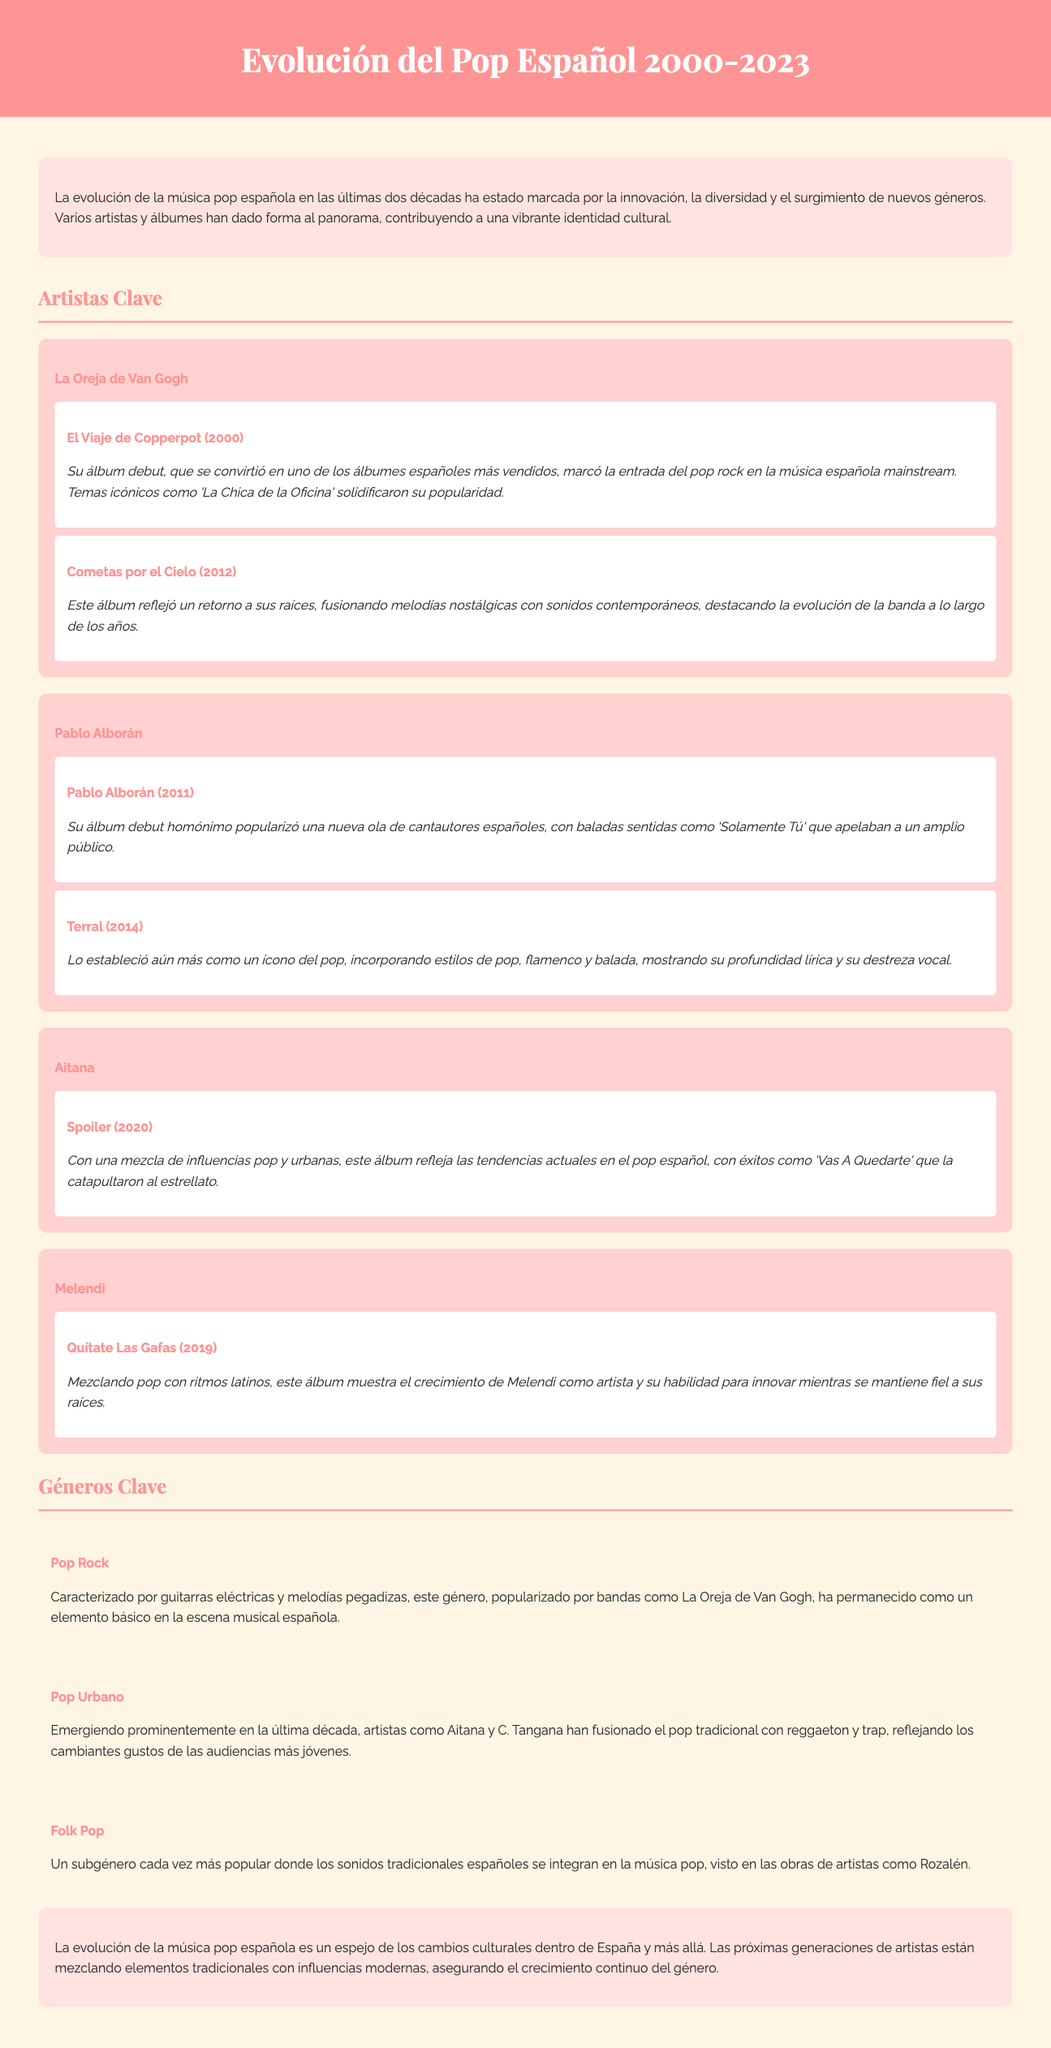¿Qué álbum debut lanzó La Oreja de Van Gogh? El álbum debut de La Oreja de Van Gogh es "El Viaje de Copperpot", que se menciona como uno de los álbumes españoles más vendidos.
Answer: El Viaje de Copperpot ¿Cuándo se lanzó "Pablo Alborán"? "Pablo Alborán" fue lanzado en 2011, según la información del documento.
Answer: 2011 ¿Qué género es característico de La Oreja de Van Gogh? El género característico de La Oreja de Van Gogh es el Pop Rock, mencionado en la sección de géneros clave.
Answer: Pop Rock ¿Cuál es el título del álbum de Aitana lanzado en 2020? El título del álbum de Aitana lanzado en 2020 es "Spoiler".
Answer: Spoiler ¿Cuál fue el impacto de "Cometas por el Cielo"? "Cometas por el Cielo" refleja un retorno a sus raíces, fusionando melodías nostálgicas con sonidos contemporáneos.
Answer: Retorno a sus raíces ¿Qué estilo de música incorpora "Terral" de Pablo Alborán? "Terral" incorpora estilos de pop, flamenco y balada, tal como se describe en el documento.
Answer: Pop, flamenco y balada ¿Quién es un artista destacado en el Pop Urbano? En el documento, Aitana es mencionada como una artista que destaca en el Pop Urbano.
Answer: Aitana ¿Cuál es el subgénero popular que integra sonidos tradicionales? El subgénero popular que integra sonidos tradicionales en el Pop se menciona como Folk Pop.
Answer: Folk Pop ¿Qué año corresponde al álbum "Quítate Las Gafas" de Melendi? "Quítate Las Gafas" de Melendi fue lanzado en 2019, según se detalla en el documento.
Answer: 2019 